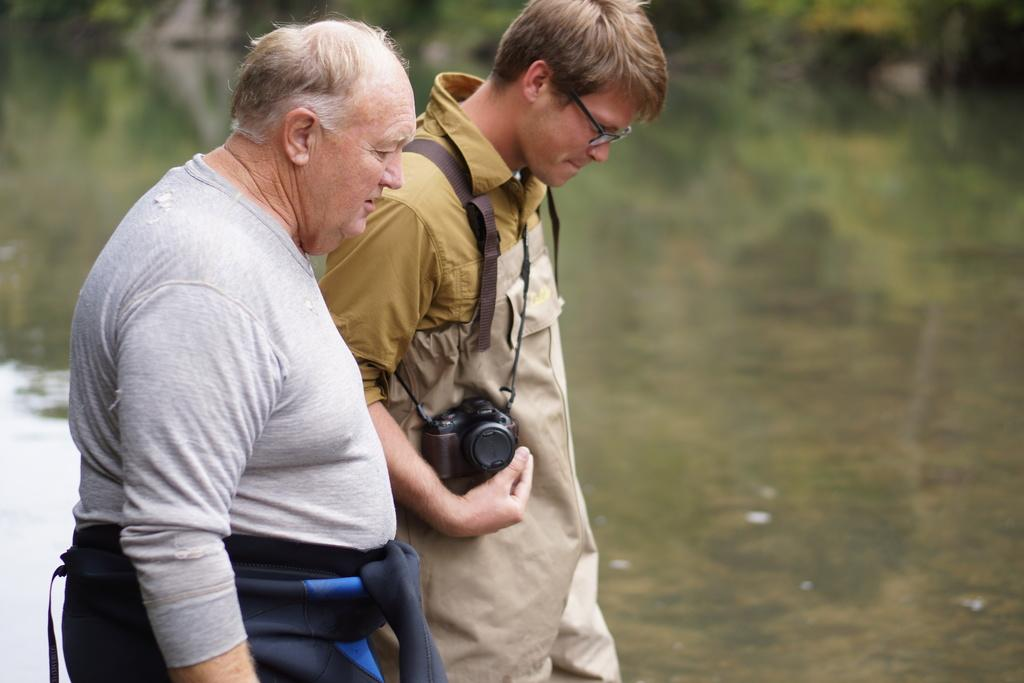Where was the image taken? The image was taken outside of the city. What are the two persons in the image doing? The two persons are taking a walk in the image. Who is holding a camera in the image? One person is holding a camera in the image. What can be seen in the background of the image? There are trees in the background of the image. How are the trees in the background depicted? The trees in the background are blurred. What type of alarm is going off in the image? There is no alarm present in the image; it features two persons taking a walk outside of the city. Can you point to the match that is being used in the image? There is no match present in the image. 